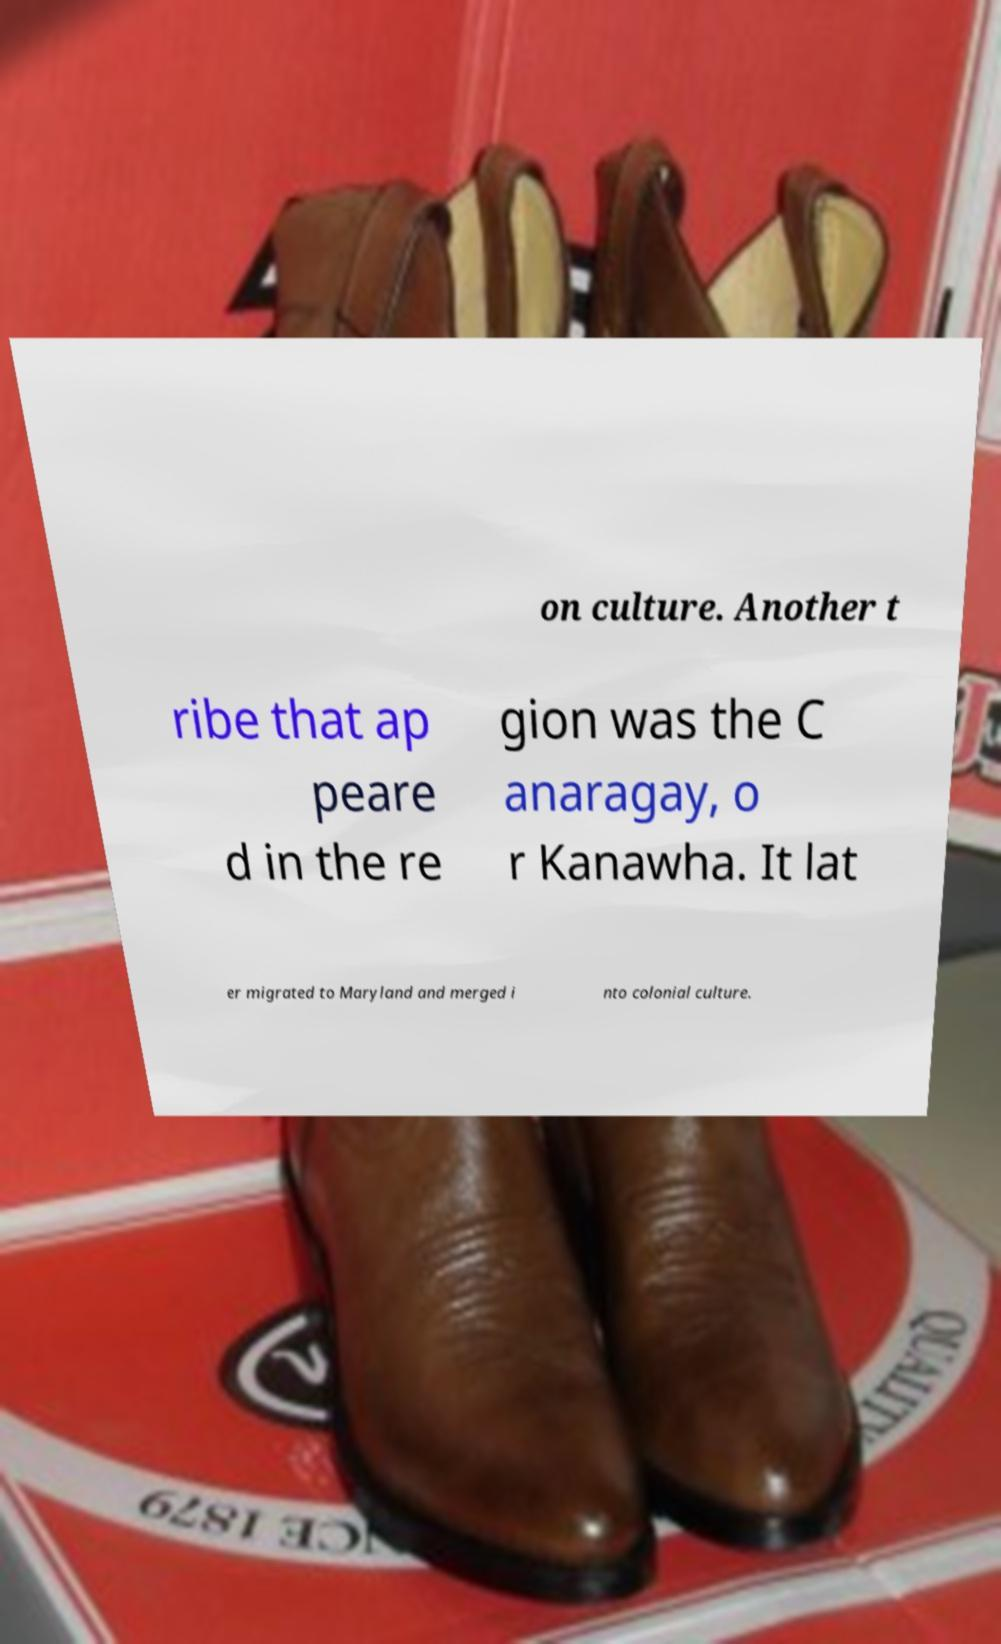Could you assist in decoding the text presented in this image and type it out clearly? on culture. Another t ribe that ap peare d in the re gion was the C anaragay, o r Kanawha. It lat er migrated to Maryland and merged i nto colonial culture. 